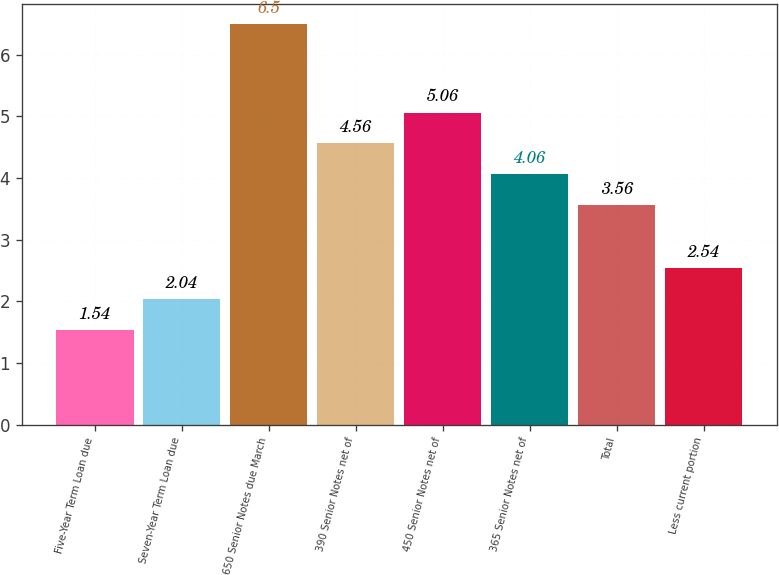Convert chart. <chart><loc_0><loc_0><loc_500><loc_500><bar_chart><fcel>Five-Year Term Loan due<fcel>Seven-Year Term Loan due<fcel>650 Senior Notes due March<fcel>390 Senior Notes net of<fcel>450 Senior Notes net of<fcel>365 Senior Notes net of<fcel>Total<fcel>Less current portion<nl><fcel>1.54<fcel>2.04<fcel>6.5<fcel>4.56<fcel>5.06<fcel>4.06<fcel>3.56<fcel>2.54<nl></chart> 